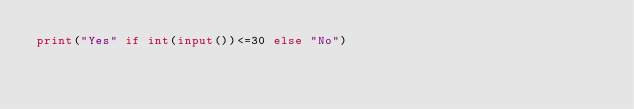Convert code to text. <code><loc_0><loc_0><loc_500><loc_500><_Python_>print("Yes" if int(input())<=30 else "No")</code> 